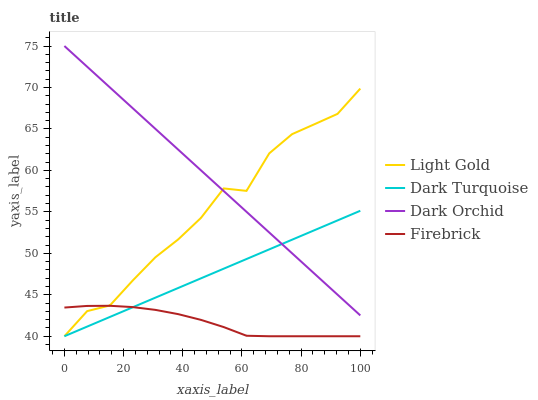Does Firebrick have the minimum area under the curve?
Answer yes or no. Yes. Does Dark Orchid have the maximum area under the curve?
Answer yes or no. Yes. Does Light Gold have the minimum area under the curve?
Answer yes or no. No. Does Light Gold have the maximum area under the curve?
Answer yes or no. No. Is Dark Orchid the smoothest?
Answer yes or no. Yes. Is Light Gold the roughest?
Answer yes or no. Yes. Is Firebrick the smoothest?
Answer yes or no. No. Is Firebrick the roughest?
Answer yes or no. No. Does Dark Turquoise have the lowest value?
Answer yes or no. Yes. Does Dark Orchid have the lowest value?
Answer yes or no. No. Does Dark Orchid have the highest value?
Answer yes or no. Yes. Does Light Gold have the highest value?
Answer yes or no. No. Is Firebrick less than Dark Orchid?
Answer yes or no. Yes. Is Dark Orchid greater than Firebrick?
Answer yes or no. Yes. Does Dark Turquoise intersect Light Gold?
Answer yes or no. Yes. Is Dark Turquoise less than Light Gold?
Answer yes or no. No. Is Dark Turquoise greater than Light Gold?
Answer yes or no. No. Does Firebrick intersect Dark Orchid?
Answer yes or no. No. 